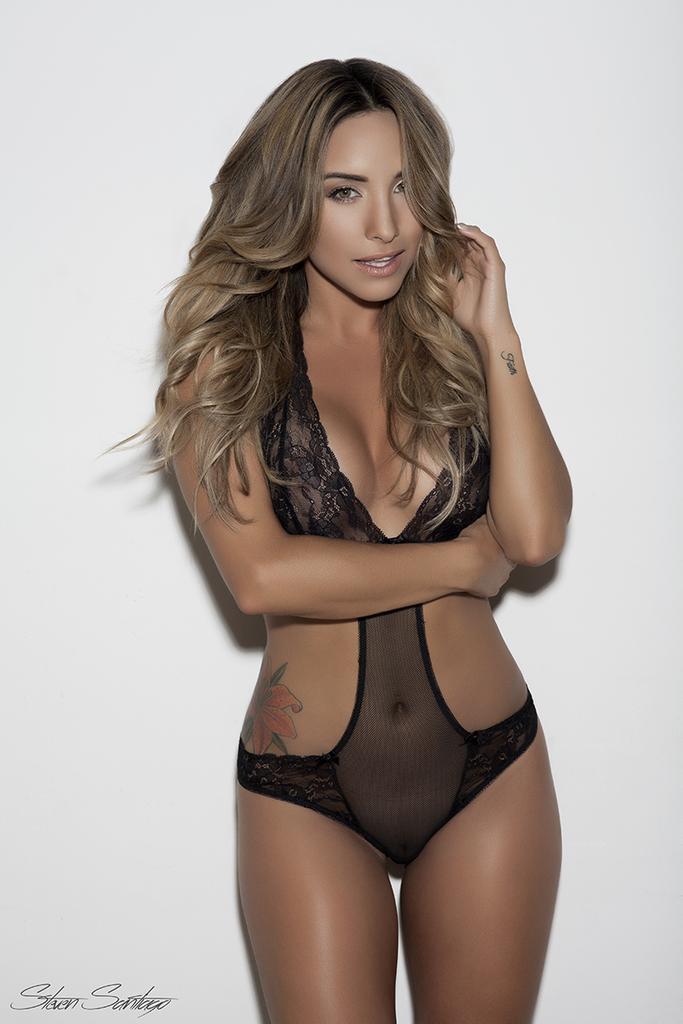Please provide a concise description of this image. In this image I can see a woman wearing black color is standing and I can see the white colored background. 